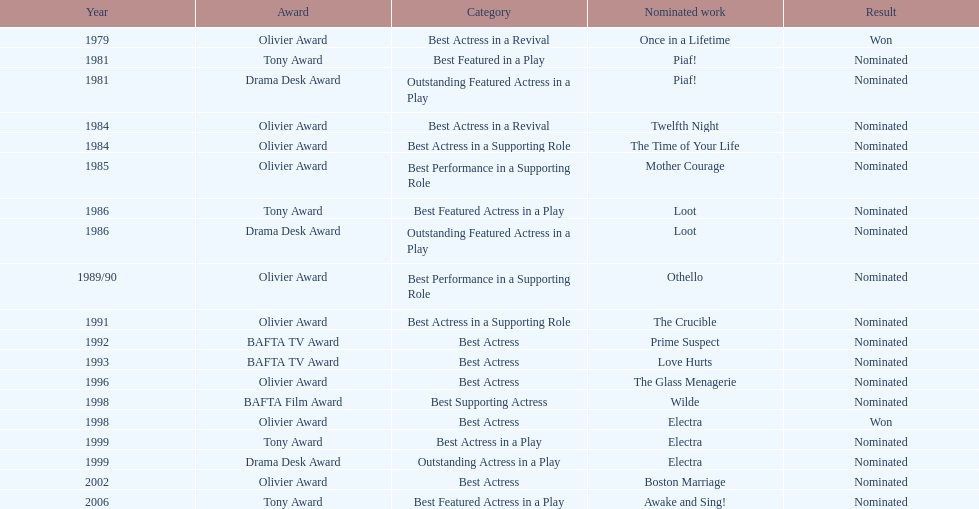Which honor was bestowed upon "once in a lifetime"? Best Actress in a Revival. 